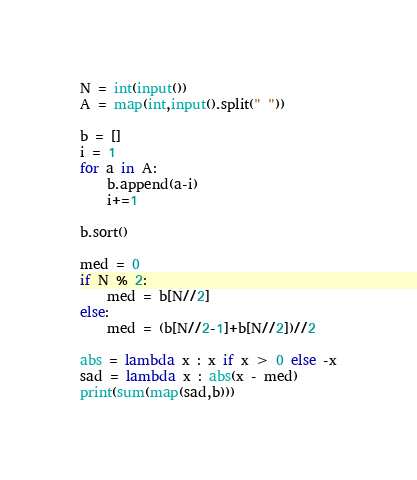Convert code to text. <code><loc_0><loc_0><loc_500><loc_500><_Python_>N = int(input())
A = map(int,input().split(" "))

b = []
i = 1
for a in A:
    b.append(a-i)
    i+=1

b.sort()

med = 0
if N % 2:
    med = b[N//2]
else:
    med = (b[N//2-1]+b[N//2])//2

abs = lambda x : x if x > 0 else -x
sad = lambda x : abs(x - med)
print(sum(map(sad,b)))</code> 